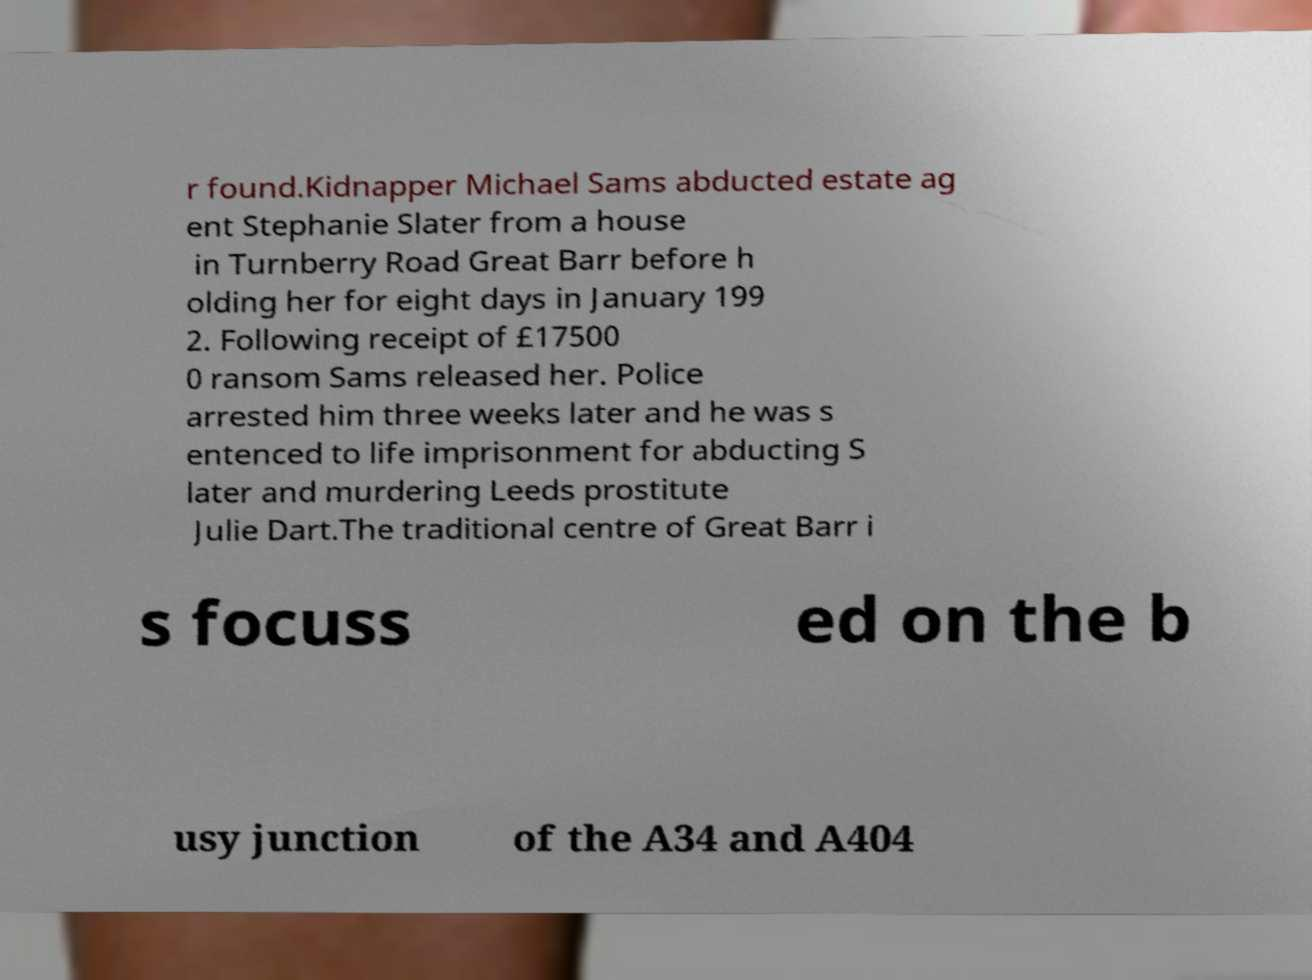Can you read and provide the text displayed in the image?This photo seems to have some interesting text. Can you extract and type it out for me? r found.Kidnapper Michael Sams abducted estate ag ent Stephanie Slater from a house in Turnberry Road Great Barr before h olding her for eight days in January 199 2. Following receipt of £17500 0 ransom Sams released her. Police arrested him three weeks later and he was s entenced to life imprisonment for abducting S later and murdering Leeds prostitute Julie Dart.The traditional centre of Great Barr i s focuss ed on the b usy junction of the A34 and A404 